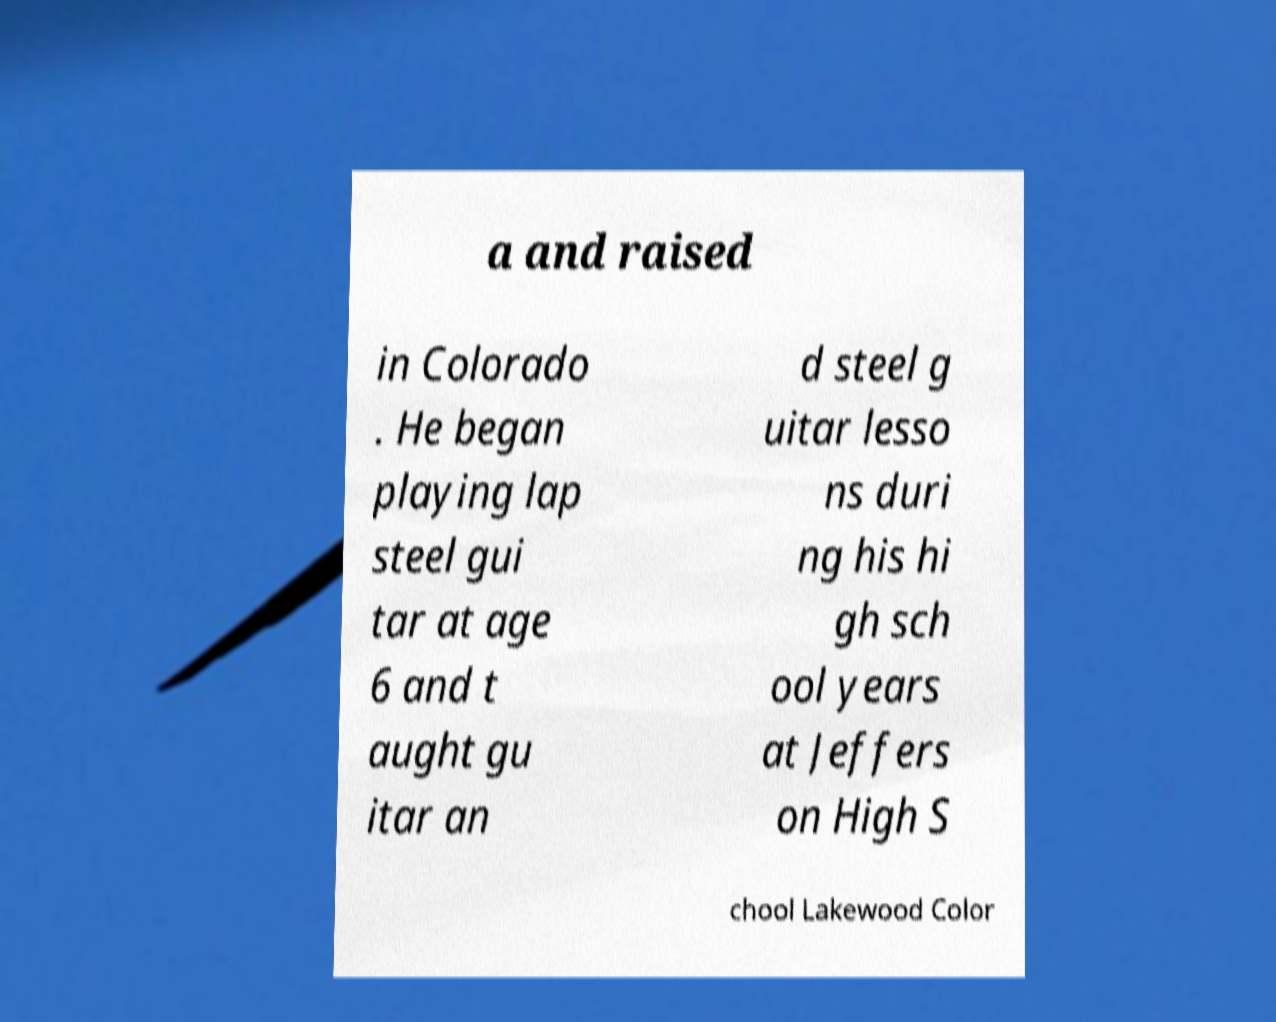There's text embedded in this image that I need extracted. Can you transcribe it verbatim? a and raised in Colorado . He began playing lap steel gui tar at age 6 and t aught gu itar an d steel g uitar lesso ns duri ng his hi gh sch ool years at Jeffers on High S chool Lakewood Color 